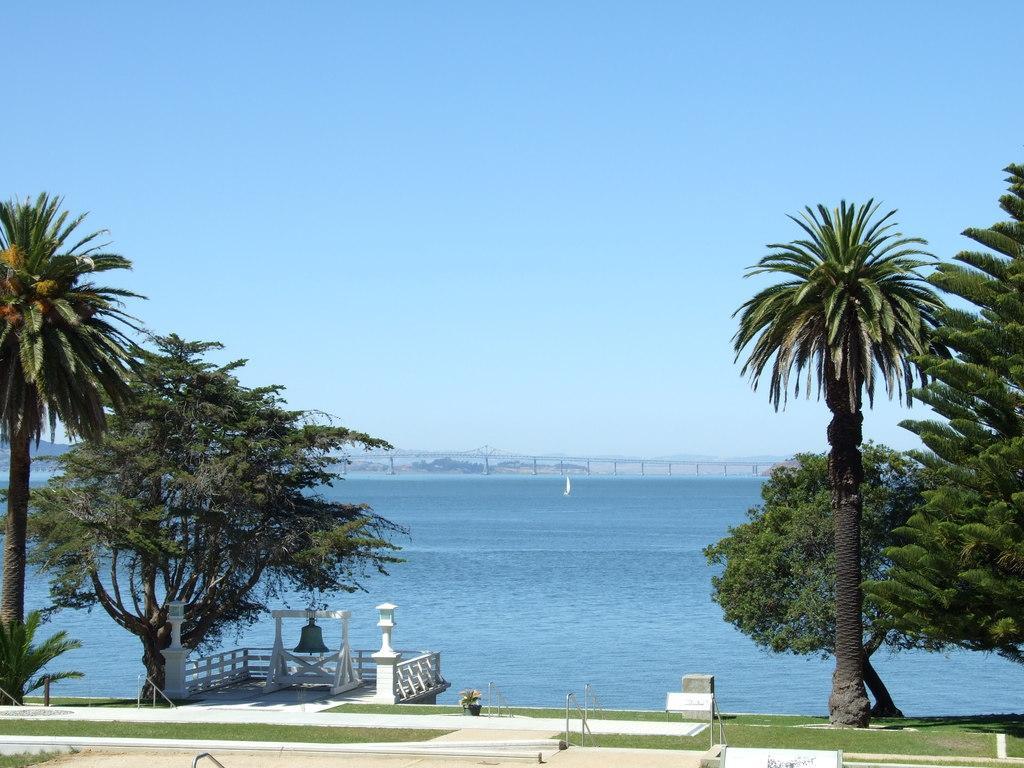Could you give a brief overview of what you see in this image? In this image, we can see some trees and grass. There is a river and bridge at the bottom of the image. There is a bell in the bottom left of the image. At the top of the image, we can see the sky. 